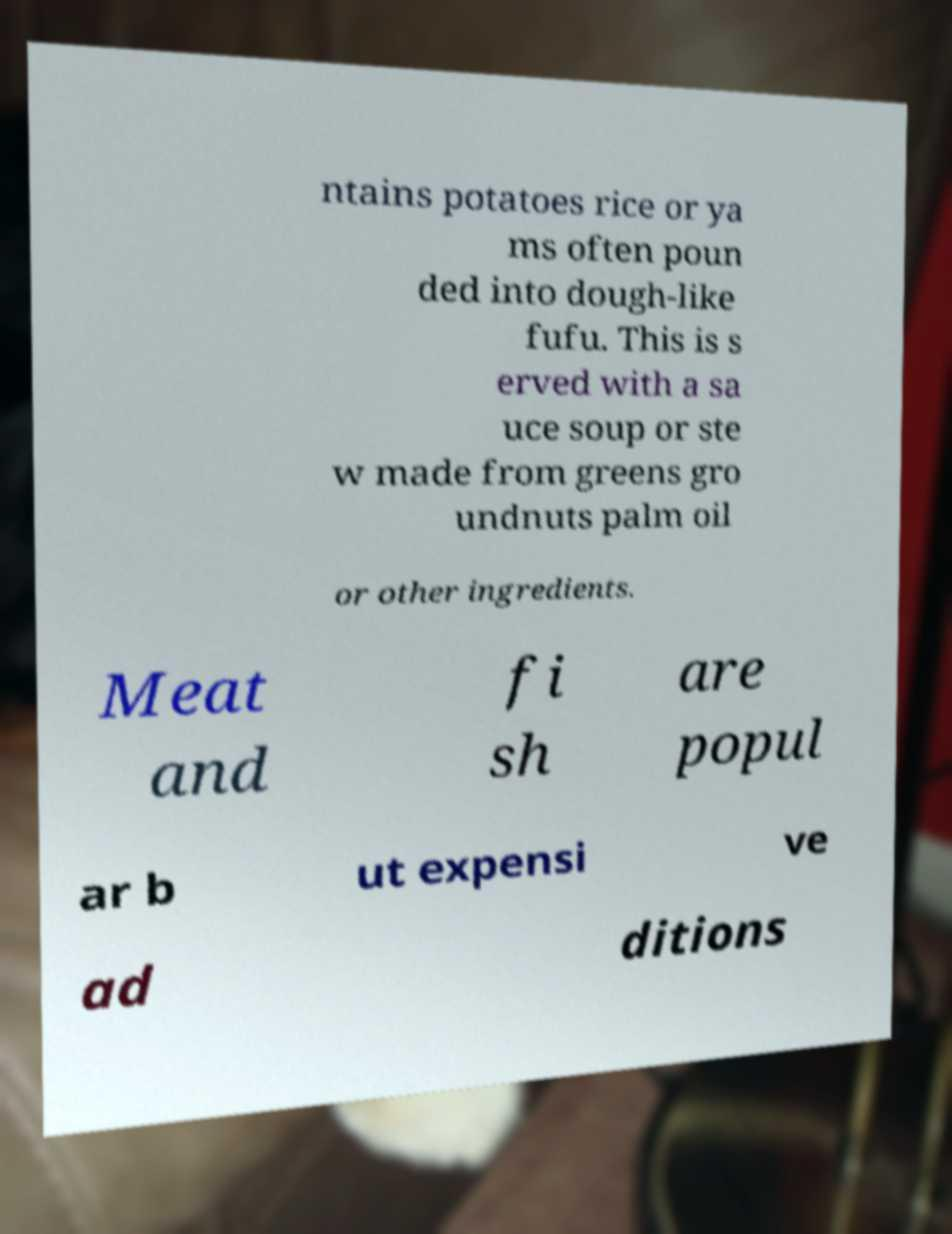Could you extract and type out the text from this image? ntains potatoes rice or ya ms often poun ded into dough-like fufu. This is s erved with a sa uce soup or ste w made from greens gro undnuts palm oil or other ingredients. Meat and fi sh are popul ar b ut expensi ve ad ditions 